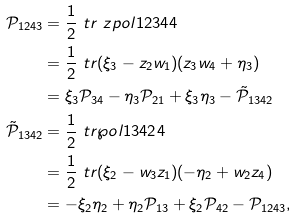<formula> <loc_0><loc_0><loc_500><loc_500>\mathcal { P } _ { 1 2 4 3 } & = \frac { 1 } { 2 } \ t r { \ z p o l { 1 2 3 4 } { 4 } } \\ & = \frac { 1 } { 2 } \ t r { ( \xi _ { 3 } - z _ { 2 } w _ { 1 } ) ( z _ { 3 } w _ { 4 } + \eta _ { 3 } ) } \\ & = \xi _ { 3 } \mathcal { P } _ { 3 4 } - \eta _ { 3 } \mathcal { P } _ { 2 1 } + \xi _ { 3 } \eta _ { 3 } - \tilde { \mathcal { P } } _ { 1 3 4 2 } \\ \tilde { \mathcal { P } } _ { 1 3 4 2 } & = \frac { 1 } { 2 } \ t r { \wp o l { 1 3 4 2 } { 4 } } \\ & = \frac { 1 } { 2 } \ t r { ( \xi _ { 2 } - w _ { 3 } z _ { 1 } ) ( - \eta _ { 2 } + w _ { 2 } z _ { 4 } ) } \\ & = - \xi _ { 2 } \eta _ { 2 } + \eta _ { 2 } \mathcal { P } _ { 1 3 } + \xi _ { 2 } \mathcal { P } _ { 4 2 } - \mathcal { P } _ { 1 2 4 3 } ,</formula> 